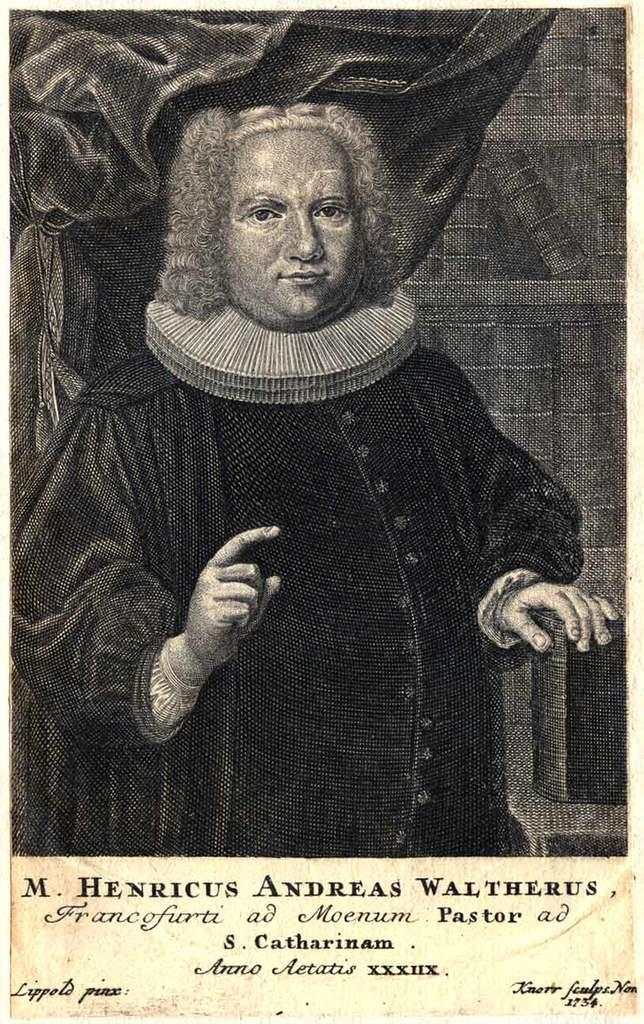What is the main subject in the image? There is a poster in the image. What type of oatmeal is being served in the image? There is no oatmeal present in the image; it only features a poster. How does the quill contribute to the design of the poster in the image? There is no quill mentioned or visible in the image; the poster is the only subject. 